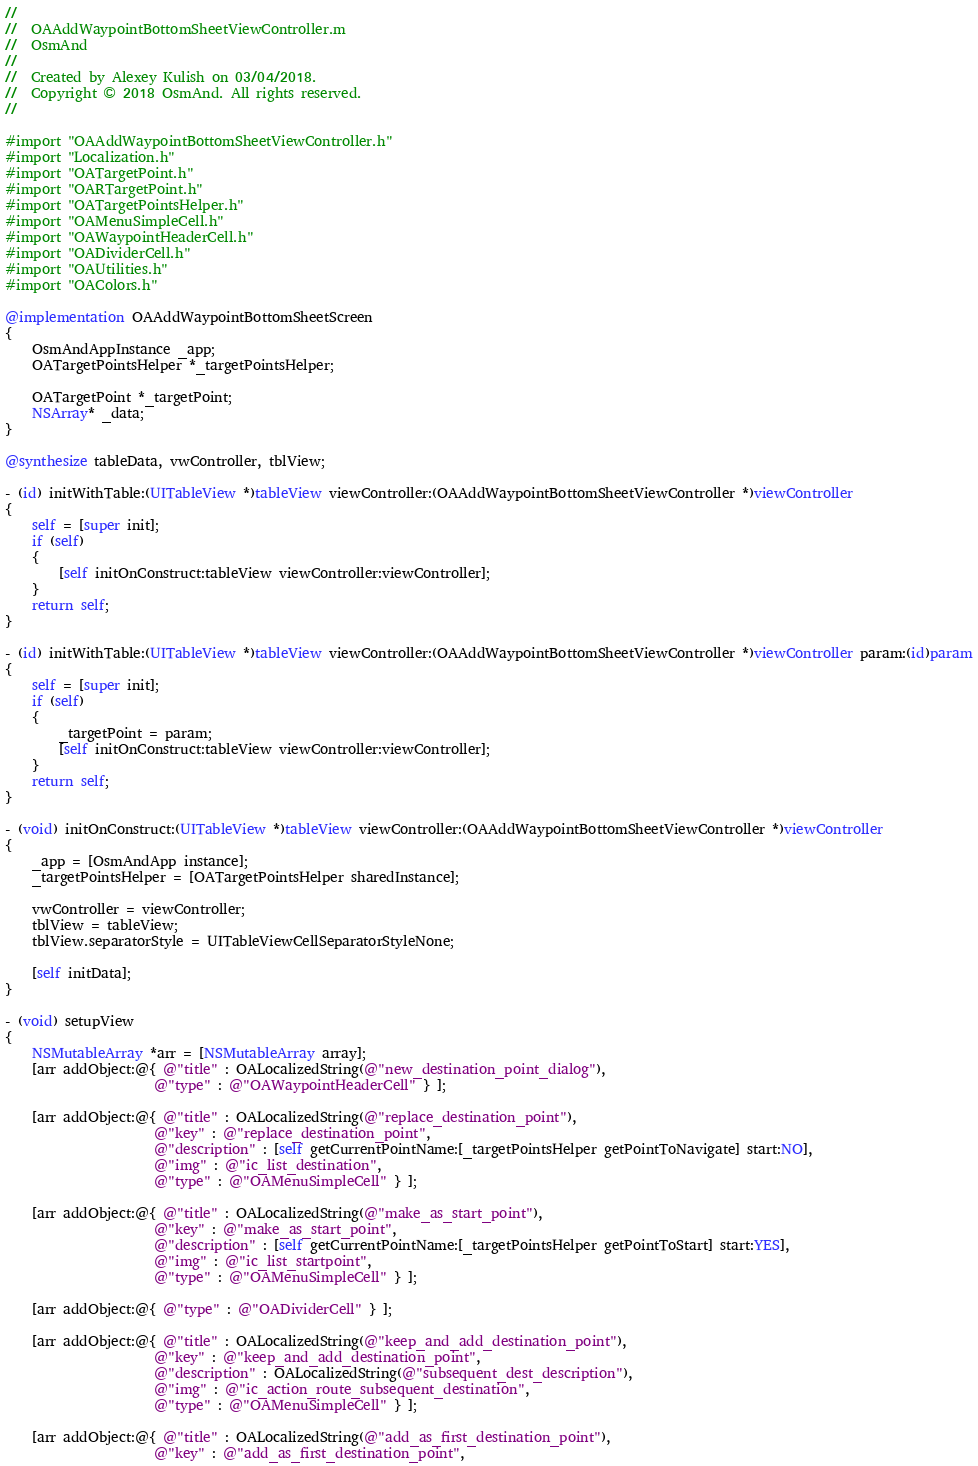Convert code to text. <code><loc_0><loc_0><loc_500><loc_500><_ObjectiveC_>//
//  OAAddWaypointBottomSheetViewController.m
//  OsmAnd
//
//  Created by Alexey Kulish on 03/04/2018.
//  Copyright © 2018 OsmAnd. All rights reserved.
//

#import "OAAddWaypointBottomSheetViewController.h"
#import "Localization.h"
#import "OATargetPoint.h"
#import "OARTargetPoint.h"
#import "OATargetPointsHelper.h"
#import "OAMenuSimpleCell.h"
#import "OAWaypointHeaderCell.h"
#import "OADividerCell.h"
#import "OAUtilities.h"
#import "OAColors.h"

@implementation OAAddWaypointBottomSheetScreen
{
    OsmAndAppInstance _app;
    OATargetPointsHelper *_targetPointsHelper;
    
    OATargetPoint *_targetPoint;
    NSArray* _data;
}

@synthesize tableData, vwController, tblView;

- (id) initWithTable:(UITableView *)tableView viewController:(OAAddWaypointBottomSheetViewController *)viewController
{
    self = [super init];
    if (self)
    {
        [self initOnConstruct:tableView viewController:viewController];
    }
    return self;
}

- (id) initWithTable:(UITableView *)tableView viewController:(OAAddWaypointBottomSheetViewController *)viewController param:(id)param
{
    self = [super init];
    if (self)
    {
        _targetPoint = param;
        [self initOnConstruct:tableView viewController:viewController];
    }
    return self;
}

- (void) initOnConstruct:(UITableView *)tableView viewController:(OAAddWaypointBottomSheetViewController *)viewController
{
    _app = [OsmAndApp instance];
    _targetPointsHelper = [OATargetPointsHelper sharedInstance];
    
    vwController = viewController;
    tblView = tableView;
    tblView.separatorStyle = UITableViewCellSeparatorStyleNone;
    
    [self initData];
}

- (void) setupView
{
    NSMutableArray *arr = [NSMutableArray array];
    [arr addObject:@{ @"title" : OALocalizedString(@"new_destination_point_dialog"),
                      @"type" : @"OAWaypointHeaderCell" } ];
    
    [arr addObject:@{ @"title" : OALocalizedString(@"replace_destination_point"),
                      @"key" : @"replace_destination_point",
                      @"description" : [self getCurrentPointName:[_targetPointsHelper getPointToNavigate] start:NO],
                      @"img" : @"ic_list_destination",
                      @"type" : @"OAMenuSimpleCell" } ];

    [arr addObject:@{ @"title" : OALocalizedString(@"make_as_start_point"),
                      @"key" : @"make_as_start_point",
                      @"description" : [self getCurrentPointName:[_targetPointsHelper getPointToStart] start:YES],
                      @"img" : @"ic_list_startpoint",
                      @"type" : @"OAMenuSimpleCell" } ];

    [arr addObject:@{ @"type" : @"OADividerCell" } ];

    [arr addObject:@{ @"title" : OALocalizedString(@"keep_and_add_destination_point"),
                      @"key" : @"keep_and_add_destination_point",
                      @"description" : OALocalizedString(@"subsequent_dest_description"),
                      @"img" : @"ic_action_route_subsequent_destination",
                      @"type" : @"OAMenuSimpleCell" } ];

    [arr addObject:@{ @"title" : OALocalizedString(@"add_as_first_destination_point"),
                      @"key" : @"add_as_first_destination_point",</code> 